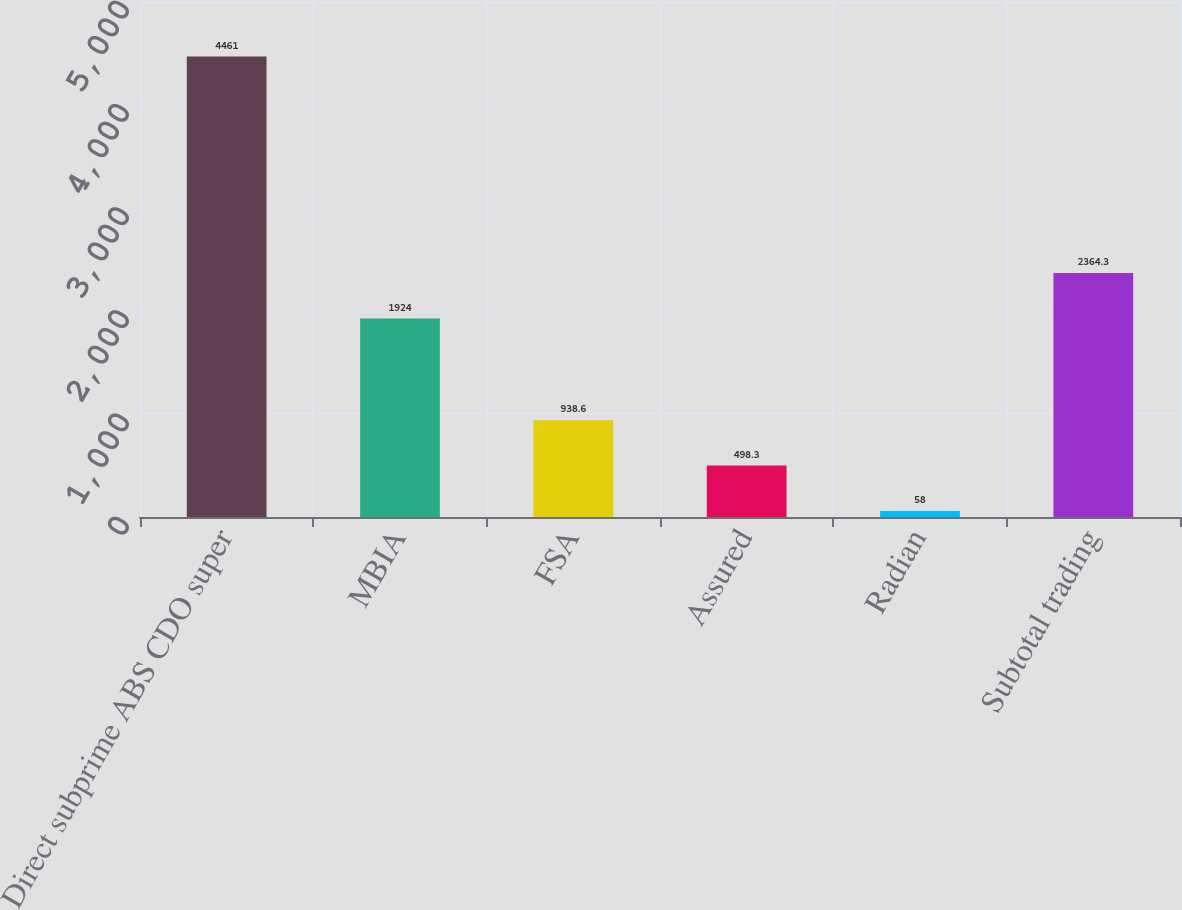Convert chart. <chart><loc_0><loc_0><loc_500><loc_500><bar_chart><fcel>Direct subprime ABS CDO super<fcel>MBIA<fcel>FSA<fcel>Assured<fcel>Radian<fcel>Subtotal trading<nl><fcel>4461<fcel>1924<fcel>938.6<fcel>498.3<fcel>58<fcel>2364.3<nl></chart> 